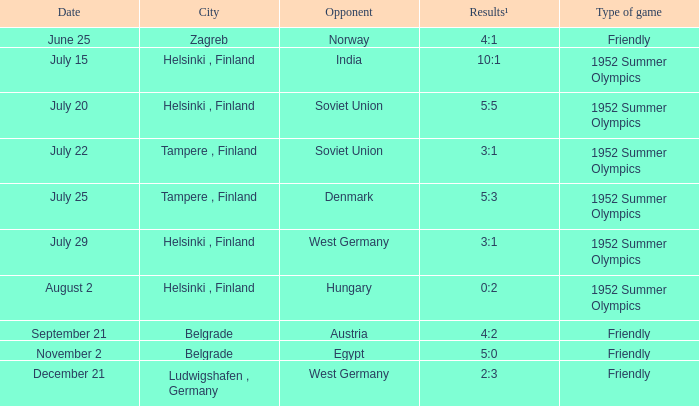In which game can a 10:1 ratio be observed in the results? 1952 Summer Olympics. 